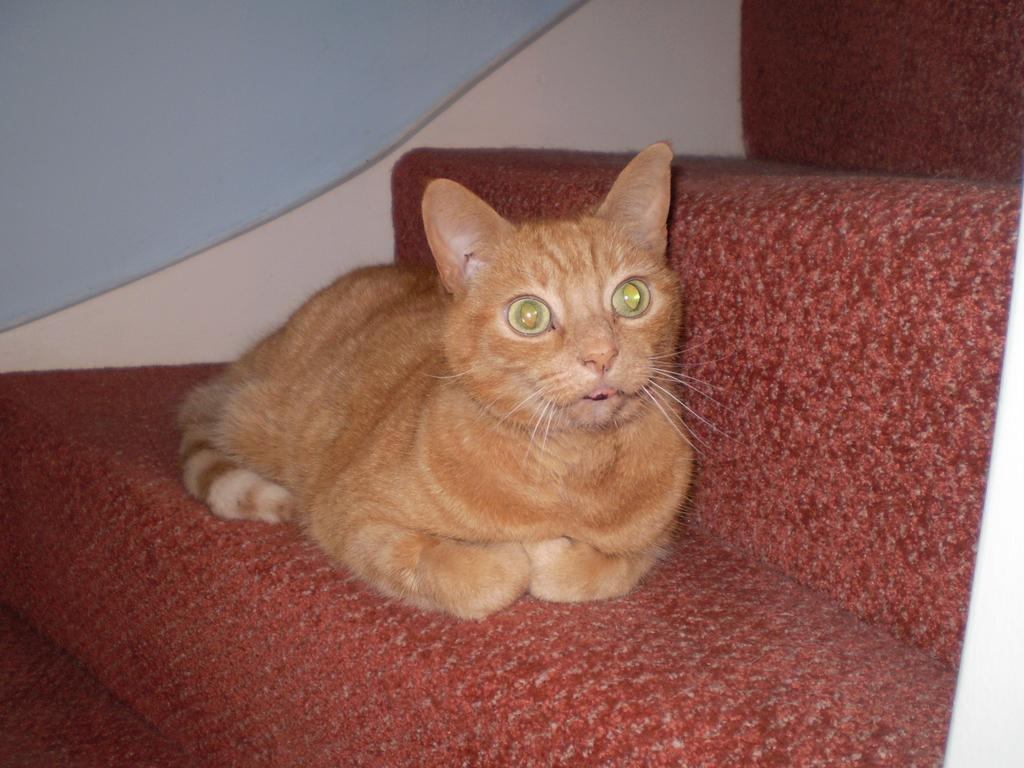What type of animal is in the image? There is a brown color cat in the image. Where is the cat located in the image? The cat is on red color stairs. What can be seen in the middle of the image? The stairs are in the middle of the image. What is visible in the background of the image? There is a wall in the background of the image. What type of lipstick is the cat wearing in the image? There is no lipstick or any indication of makeup on the cat in the image. 